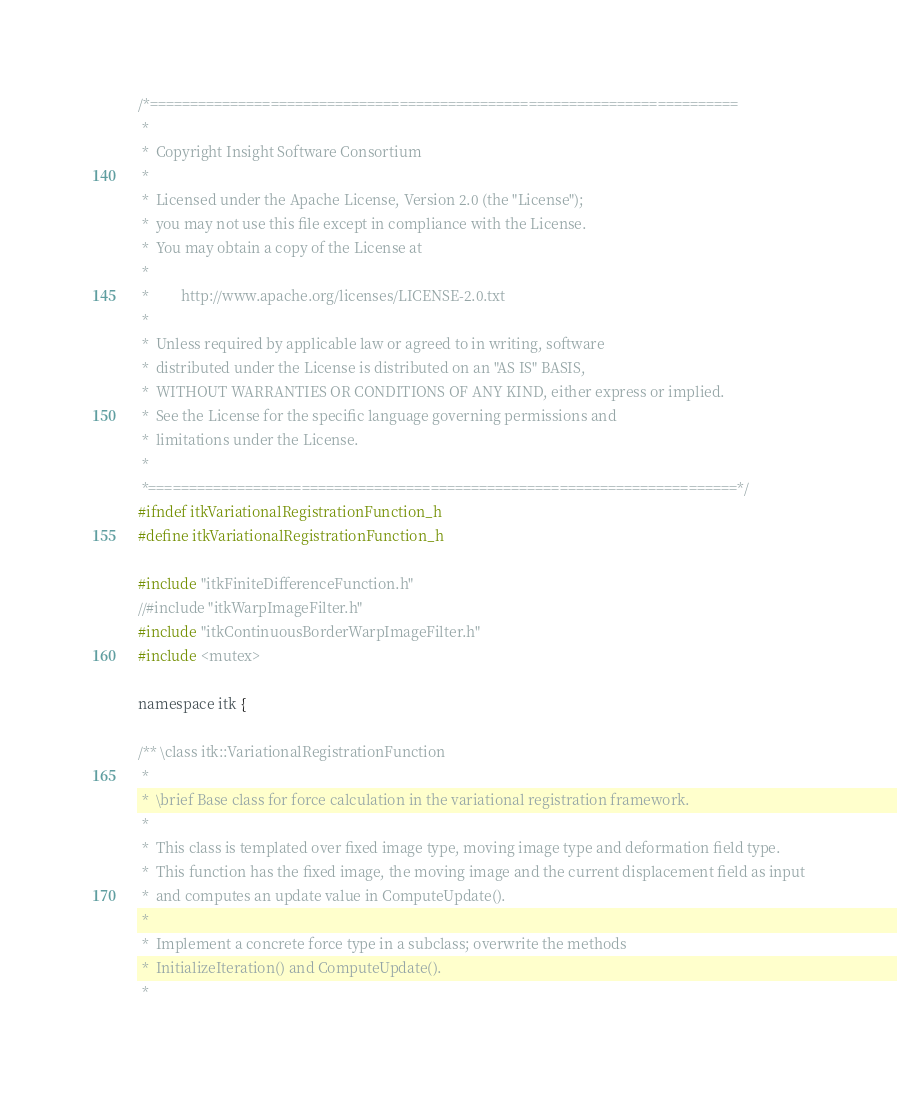<code> <loc_0><loc_0><loc_500><loc_500><_C_>/*=========================================================================
 *
 *  Copyright Insight Software Consortium
 *
 *  Licensed under the Apache License, Version 2.0 (the "License");
 *  you may not use this file except in compliance with the License.
 *  You may obtain a copy of the License at
 *
 *         http://www.apache.org/licenses/LICENSE-2.0.txt
 *
 *  Unless required by applicable law or agreed to in writing, software
 *  distributed under the License is distributed on an "AS IS" BASIS,
 *  WITHOUT WARRANTIES OR CONDITIONS OF ANY KIND, either express or implied.
 *  See the License for the specific language governing permissions and
 *  limitations under the License.
 *
 *=========================================================================*/
#ifndef itkVariationalRegistrationFunction_h
#define itkVariationalRegistrationFunction_h

#include "itkFiniteDifferenceFunction.h"
//#include "itkWarpImageFilter.h"
#include "itkContinuousBorderWarpImageFilter.h"
#include <mutex>

namespace itk {

/** \class itk::VariationalRegistrationFunction
 *
 *  \brief Base class for force calculation in the variational registration framework.
 *
 *  This class is templated over fixed image type, moving image type and deformation field type.
 *  This function has the fixed image, the moving image and the current displacement field as input
 *  and computes an update value in ComputeUpdate().
 *
 *  Implement a concrete force type in a subclass; overwrite the methods
 *  InitializeIteration() and ComputeUpdate().
 *</code> 